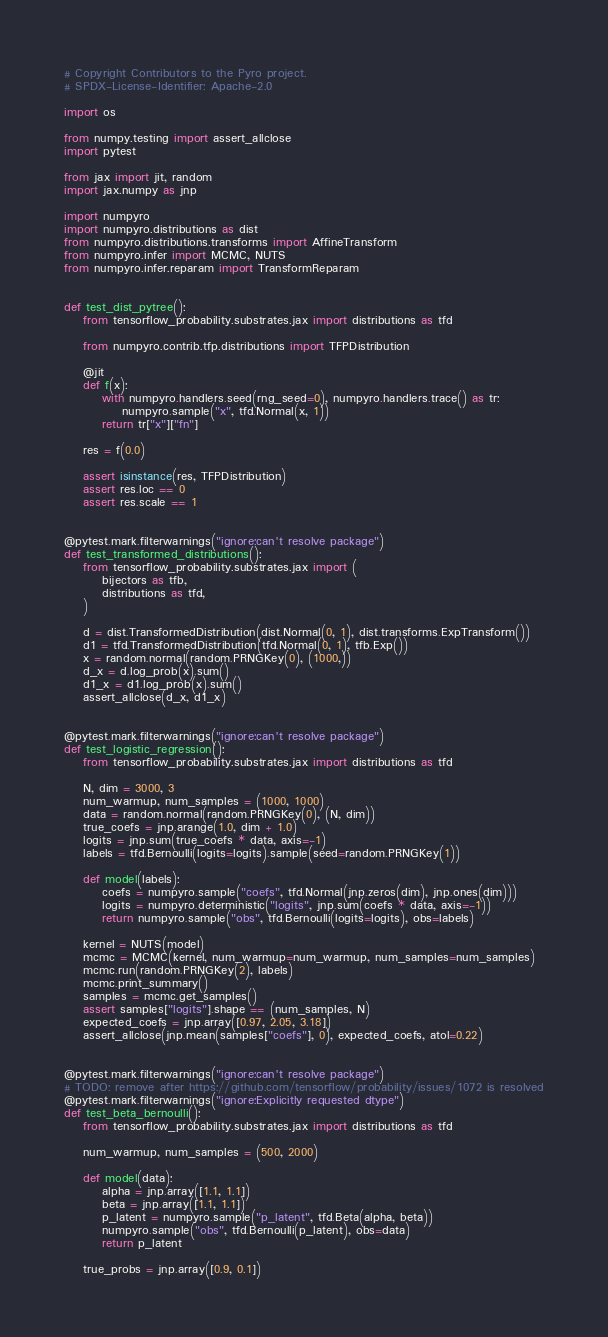Convert code to text. <code><loc_0><loc_0><loc_500><loc_500><_Python_># Copyright Contributors to the Pyro project.
# SPDX-License-Identifier: Apache-2.0

import os

from numpy.testing import assert_allclose
import pytest

from jax import jit, random
import jax.numpy as jnp

import numpyro
import numpyro.distributions as dist
from numpyro.distributions.transforms import AffineTransform
from numpyro.infer import MCMC, NUTS
from numpyro.infer.reparam import TransformReparam


def test_dist_pytree():
    from tensorflow_probability.substrates.jax import distributions as tfd

    from numpyro.contrib.tfp.distributions import TFPDistribution

    @jit
    def f(x):
        with numpyro.handlers.seed(rng_seed=0), numpyro.handlers.trace() as tr:
            numpyro.sample("x", tfd.Normal(x, 1))
        return tr["x"]["fn"]

    res = f(0.0)

    assert isinstance(res, TFPDistribution)
    assert res.loc == 0
    assert res.scale == 1


@pytest.mark.filterwarnings("ignore:can't resolve package")
def test_transformed_distributions():
    from tensorflow_probability.substrates.jax import (
        bijectors as tfb,
        distributions as tfd,
    )

    d = dist.TransformedDistribution(dist.Normal(0, 1), dist.transforms.ExpTransform())
    d1 = tfd.TransformedDistribution(tfd.Normal(0, 1), tfb.Exp())
    x = random.normal(random.PRNGKey(0), (1000,))
    d_x = d.log_prob(x).sum()
    d1_x = d1.log_prob(x).sum()
    assert_allclose(d_x, d1_x)


@pytest.mark.filterwarnings("ignore:can't resolve package")
def test_logistic_regression():
    from tensorflow_probability.substrates.jax import distributions as tfd

    N, dim = 3000, 3
    num_warmup, num_samples = (1000, 1000)
    data = random.normal(random.PRNGKey(0), (N, dim))
    true_coefs = jnp.arange(1.0, dim + 1.0)
    logits = jnp.sum(true_coefs * data, axis=-1)
    labels = tfd.Bernoulli(logits=logits).sample(seed=random.PRNGKey(1))

    def model(labels):
        coefs = numpyro.sample("coefs", tfd.Normal(jnp.zeros(dim), jnp.ones(dim)))
        logits = numpyro.deterministic("logits", jnp.sum(coefs * data, axis=-1))
        return numpyro.sample("obs", tfd.Bernoulli(logits=logits), obs=labels)

    kernel = NUTS(model)
    mcmc = MCMC(kernel, num_warmup=num_warmup, num_samples=num_samples)
    mcmc.run(random.PRNGKey(2), labels)
    mcmc.print_summary()
    samples = mcmc.get_samples()
    assert samples["logits"].shape == (num_samples, N)
    expected_coefs = jnp.array([0.97, 2.05, 3.18])
    assert_allclose(jnp.mean(samples["coefs"], 0), expected_coefs, atol=0.22)


@pytest.mark.filterwarnings("ignore:can't resolve package")
# TODO: remove after https://github.com/tensorflow/probability/issues/1072 is resolved
@pytest.mark.filterwarnings("ignore:Explicitly requested dtype")
def test_beta_bernoulli():
    from tensorflow_probability.substrates.jax import distributions as tfd

    num_warmup, num_samples = (500, 2000)

    def model(data):
        alpha = jnp.array([1.1, 1.1])
        beta = jnp.array([1.1, 1.1])
        p_latent = numpyro.sample("p_latent", tfd.Beta(alpha, beta))
        numpyro.sample("obs", tfd.Bernoulli(p_latent), obs=data)
        return p_latent

    true_probs = jnp.array([0.9, 0.1])</code> 